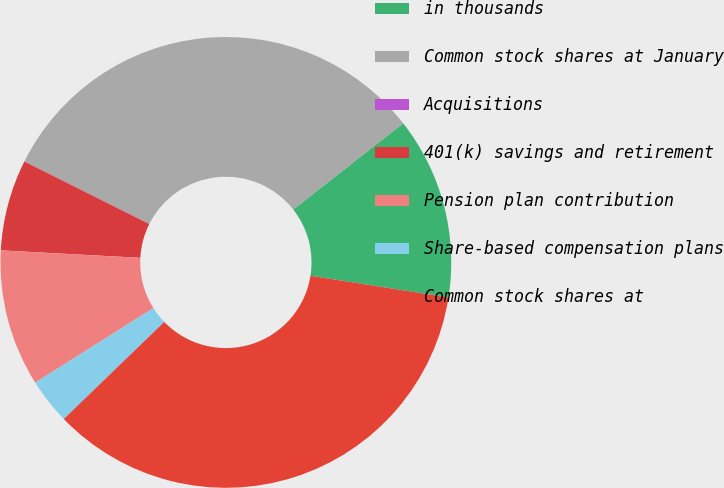<chart> <loc_0><loc_0><loc_500><loc_500><pie_chart><fcel>in thousands<fcel>Common stock shares at January<fcel>Acquisitions<fcel>401(k) savings and retirement<fcel>Pension plan contribution<fcel>Share-based compensation plans<fcel>Common stock shares at<nl><fcel>13.08%<fcel>32.02%<fcel>0.0%<fcel>6.54%<fcel>9.81%<fcel>3.27%<fcel>35.29%<nl></chart> 